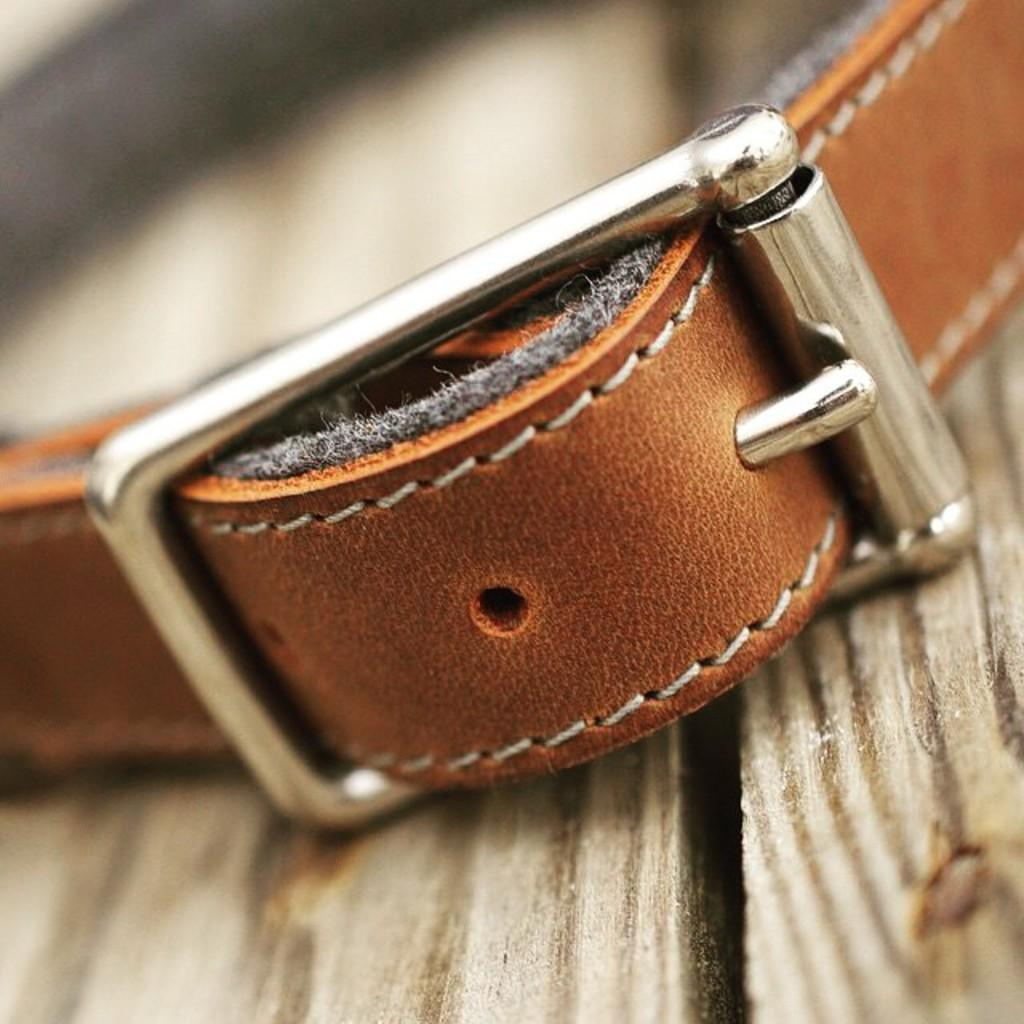What object can be seen in the image? There is a belt in the image. Can you describe the background of the image? The background of the image is blurry. What type of paste is being used in the game depicted in the image? There is no game or paste present in the image; it only features a belt and a blurry background. 